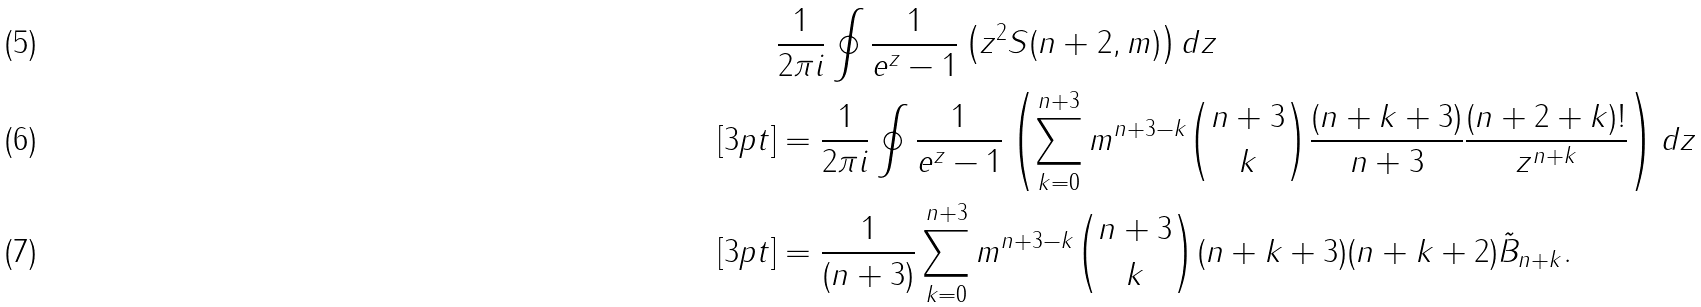<formula> <loc_0><loc_0><loc_500><loc_500>& \frac { 1 } { 2 \pi i } \oint \frac { 1 } { e ^ { z } - 1 } \left ( z ^ { 2 } S ( n + 2 , m ) \right ) d z \\ [ 3 p t ] & = \frac { 1 } { 2 \pi i } \oint \frac { 1 } { e ^ { z } - 1 } \left ( \sum _ { k = 0 } ^ { n + 3 } m ^ { n + 3 - k } { n + 3 \choose k } \frac { ( n + k + 3 ) } { n + 3 } \frac { ( n + 2 + k ) ! } { z ^ { n + k } } \right ) d z \\ [ 3 p t ] & = \frac { 1 } { ( n + 3 ) } \sum _ { k = 0 } ^ { n + 3 } m ^ { n + 3 - k } { n + 3 \choose k } ( n + k + 3 ) ( n + k + 2 ) \tilde { B } _ { n + k } .</formula> 